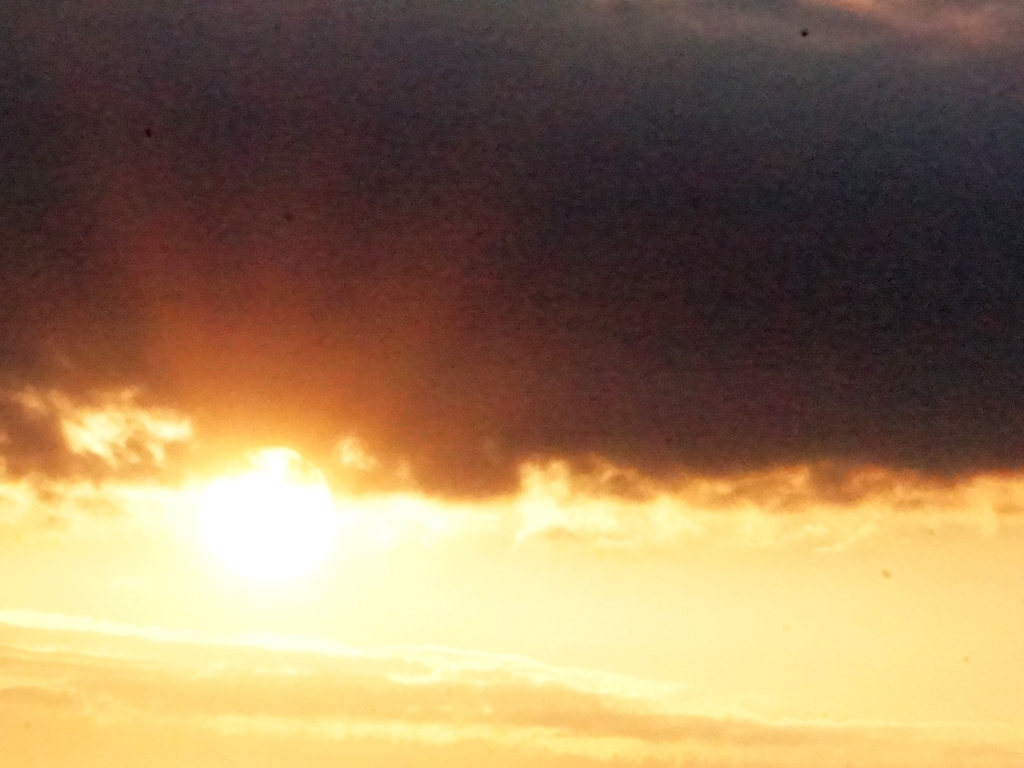Can you describe the composition of this image? The image is composed with a dominant sun placed off-center, surrounded by a blend of warm and cool tones. The dark cloud bisects the frame, adding contrast and a sense of impending transition in the sky. 